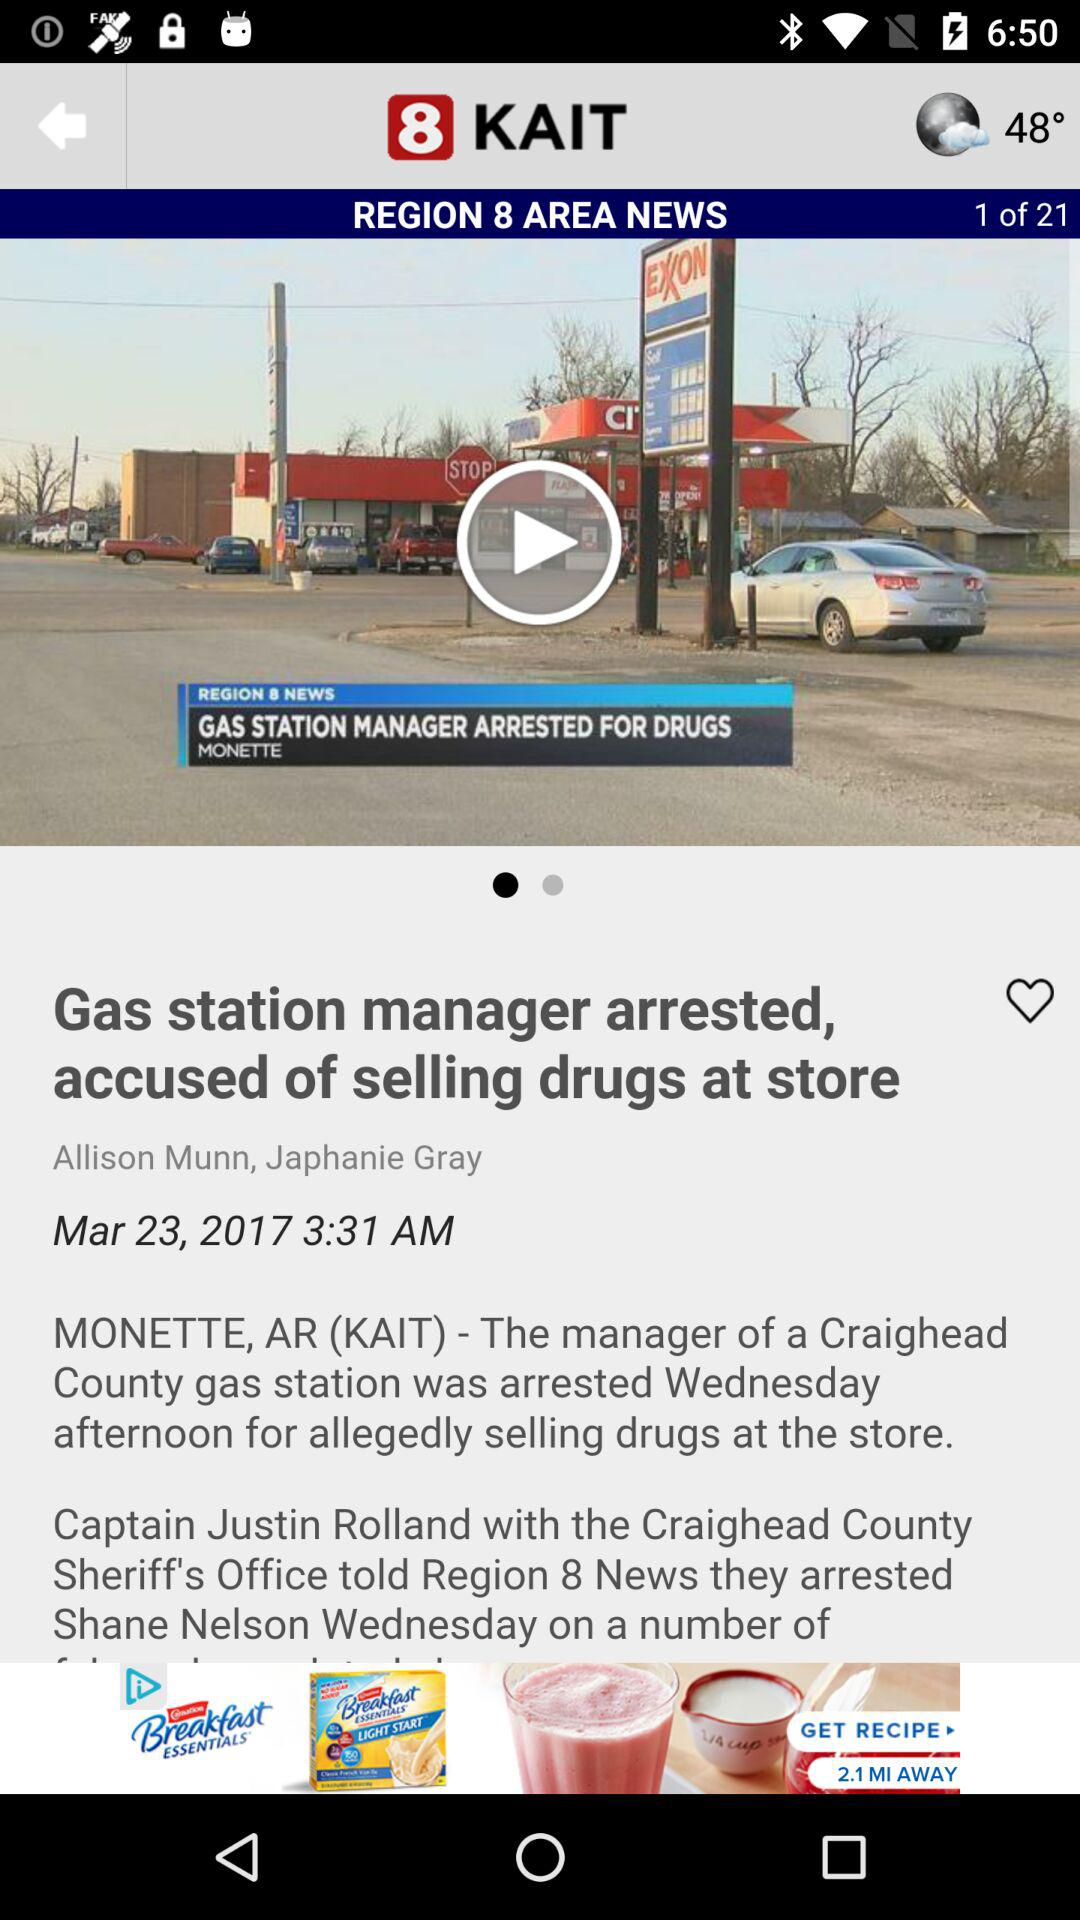What is the author's name? The authors are "Allison Munn" and "Japhanie Gray". 